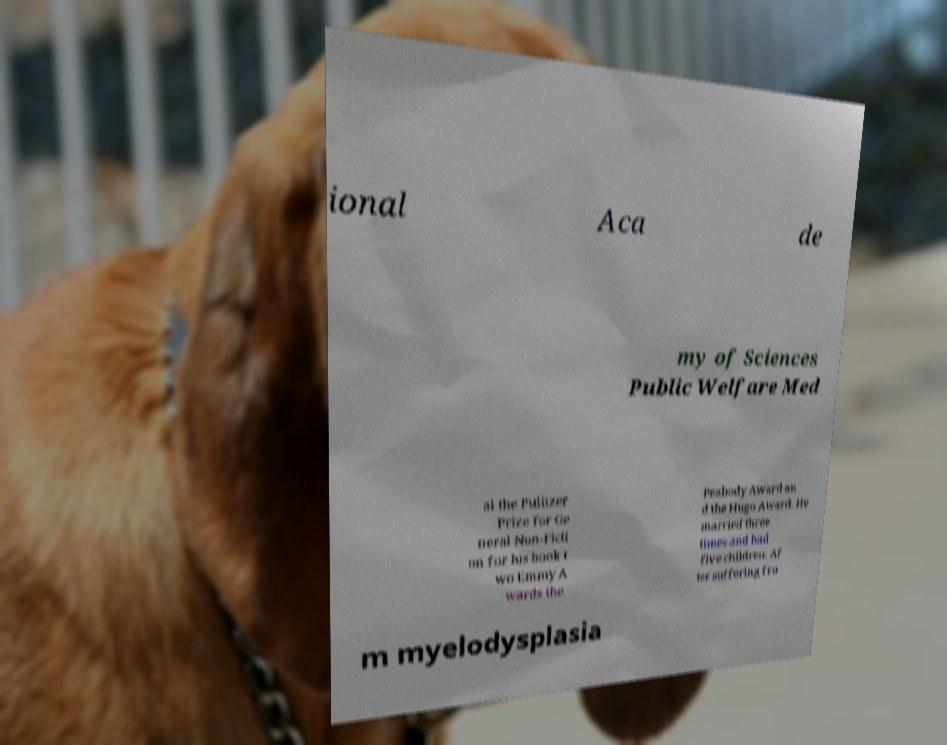There's text embedded in this image that I need extracted. Can you transcribe it verbatim? ional Aca de my of Sciences Public Welfare Med al the Pulitzer Prize for Ge neral Non-Ficti on for his book t wo Emmy A wards the Peabody Award an d the Hugo Award. He married three times and had five children. Af ter suffering fro m myelodysplasia 